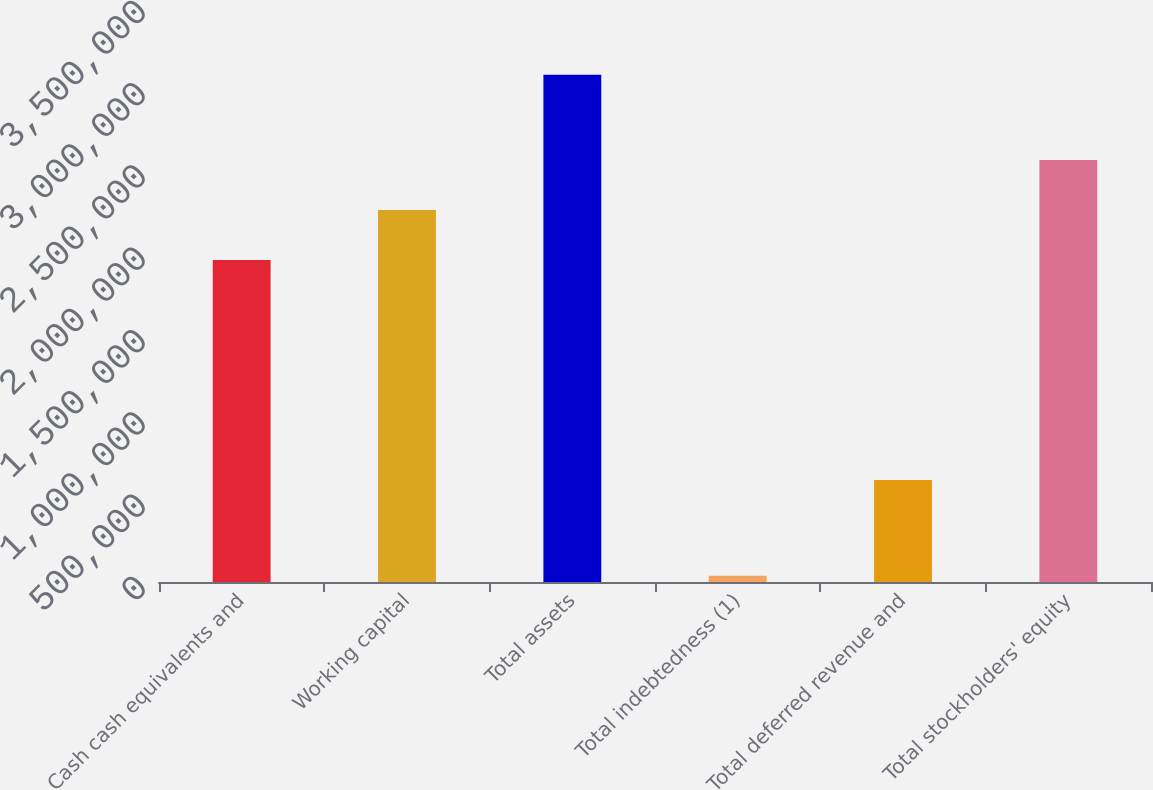<chart> <loc_0><loc_0><loc_500><loc_500><bar_chart><fcel>Cash cash equivalents and<fcel>Working capital<fcel>Total assets<fcel>Total indebtedness (1)<fcel>Total deferred revenue and<fcel>Total stockholders' equity<nl><fcel>1.95615e+06<fcel>2.26057e+06<fcel>3.08198e+06<fcel>37743<fcel>619822<fcel>2.565e+06<nl></chart> 